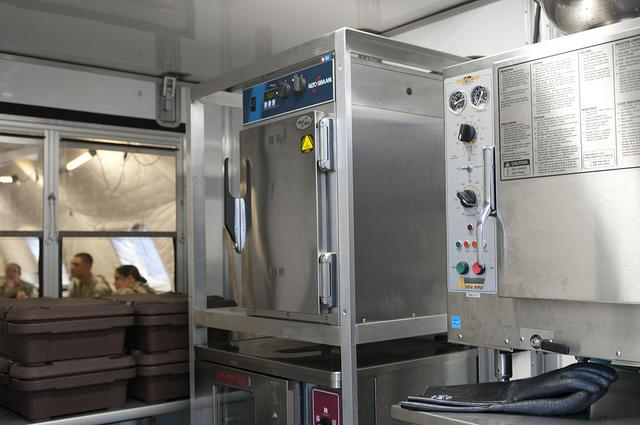What type of kitchen is this? Please explain your reasoning. commercial. This kitchen contains large steel industrial appliances with controls that are different from controls on home kitchen appliances. 